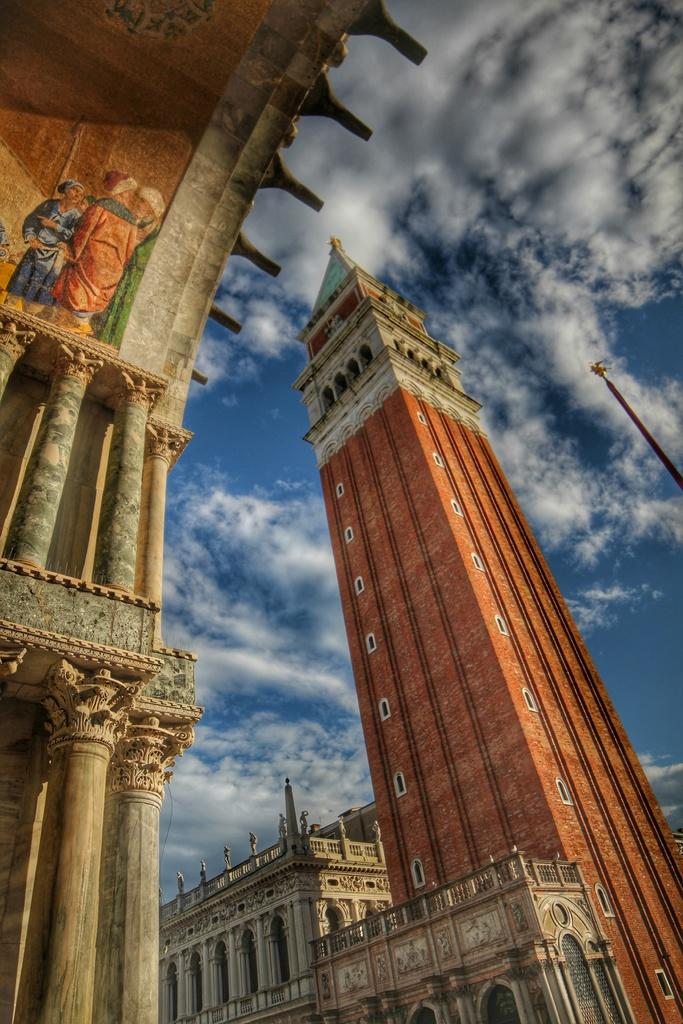What type of structures can be seen in the image? There are buildings in the image. What part of the natural environment is visible in the image? The sky is visible in the background of the image. What emotion does the building in the image express? Buildings do not express emotions; they are inanimate objects. 